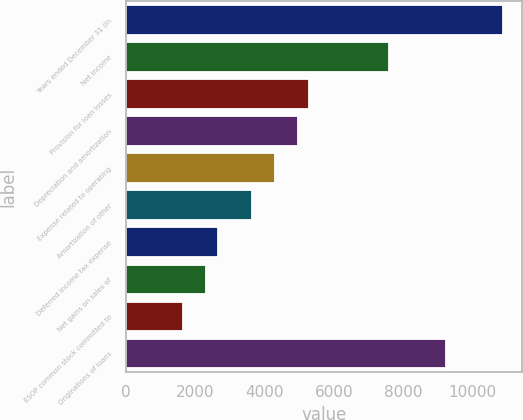<chart> <loc_0><loc_0><loc_500><loc_500><bar_chart><fcel>Years ended December 31 (in<fcel>Net income<fcel>Provision for loan losses<fcel>Depreciation and amortization<fcel>Expense related to operating<fcel>Amortization of other<fcel>Deferred income tax expense<fcel>Net gains on sales of<fcel>ESOP common stock committed to<fcel>Originations of loans<nl><fcel>10898.5<fcel>7595.95<fcel>5284.2<fcel>4953.95<fcel>4293.45<fcel>3632.95<fcel>2642.2<fcel>2311.95<fcel>1651.45<fcel>9247.2<nl></chart> 